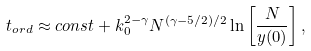<formula> <loc_0><loc_0><loc_500><loc_500>t _ { o r d } \approx c o n s t + k _ { 0 } ^ { 2 - \gamma } N ^ { ( \gamma - 5 / 2 ) / 2 } \ln \left [ \frac { N } { y ( 0 ) } \right ] ,</formula> 